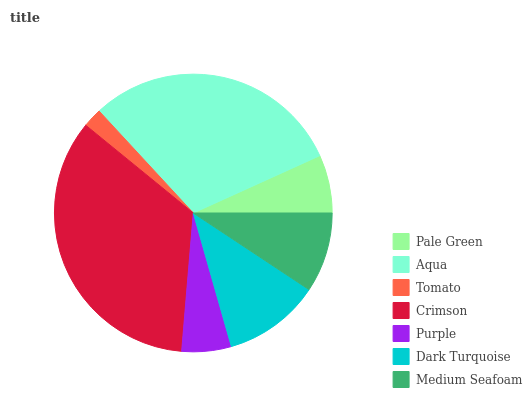Is Tomato the minimum?
Answer yes or no. Yes. Is Crimson the maximum?
Answer yes or no. Yes. Is Aqua the minimum?
Answer yes or no. No. Is Aqua the maximum?
Answer yes or no. No. Is Aqua greater than Pale Green?
Answer yes or no. Yes. Is Pale Green less than Aqua?
Answer yes or no. Yes. Is Pale Green greater than Aqua?
Answer yes or no. No. Is Aqua less than Pale Green?
Answer yes or no. No. Is Medium Seafoam the high median?
Answer yes or no. Yes. Is Medium Seafoam the low median?
Answer yes or no. Yes. Is Aqua the high median?
Answer yes or no. No. Is Tomato the low median?
Answer yes or no. No. 